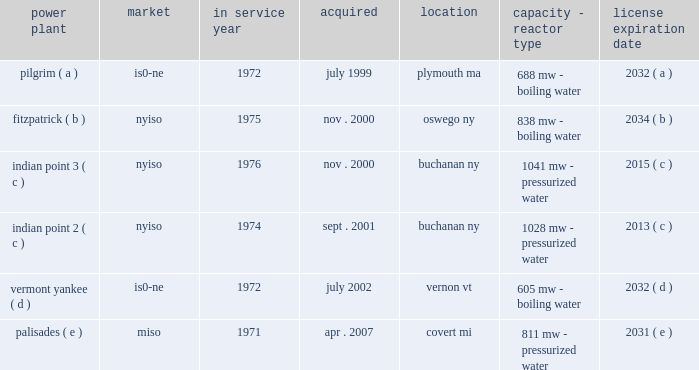Part i item 1 entergy corporation , utility operating companies , and system energy including the continued effectiveness of the clean energy standards/zero emissions credit program ( ces/zec ) , the establishment of certain long-term agreements on acceptable terms with the energy research and development authority of the state of new york in connection with the ces/zec program , and nypsc approval of the transaction on acceptable terms , entergy refueled the fitzpatrick plant in january and february 2017 .
In october 2015 , entergy determined that it would close the pilgrim plant .
The decision came after management 2019s extensive analysis of the economics and operating life of the plant following the nrc 2019s decision in september 2015 to place the plant in its 201cmultiple/repetitive degraded cornerstone column 201d ( column 4 ) of its reactor oversight process action matrix .
The pilgrim plant is expected to cease operations on may 31 , 2019 , after refueling in the spring of 2017 and operating through the end of that fuel cycle .
In december 2015 , entergy wholesale commodities closed on the sale of its 583 mw rhode island state energy center ( risec ) , in johnston , rhode island .
The base sales price , excluding adjustments , was approximately $ 490 million .
Entergy wholesale commodities purchased risec for $ 346 million in december 2011 .
In december 2016 , entergy announced that it reached an agreement with consumers energy to terminate the ppa for the palisades plant on may 31 , 2018 .
Pursuant to the ppa termination agreement , consumers energy will pay entergy $ 172 million for the early termination of the ppa .
The ppa termination agreement is subject to regulatory approvals .
Separately , and assuming regulatory approvals are obtained for the ppa termination agreement , entergy intends to shut down the palisades nuclear power plant permanently on october 1 , 2018 , after refueling in the spring of 2017 and operating through the end of that fuel cycle .
Entergy expects to enter into a new ppa with consumers energy under which the plant would continue to operate through october 1 , 2018 .
In january 2017 , entergy announced that it reached a settlement with new york state to shut down indian point 2 by april 30 , 2020 and indian point 3 by april 30 , 2021 , and resolve all new york state-initiated legal challenges to indian point 2019s operating license renewal .
As part of the settlement , new york state has agreed to issue indian point 2019s water quality certification and coastal zone management act consistency certification and to withdraw its objection to license renewal before the nrc .
New york state also has agreed to issue a water discharge permit , which is required regardless of whether the plant is seeking a renewed nrc license .
The shutdowns are conditioned , among other things , upon such actions being taken by new york state .
Even without opposition , the nrc license renewal process is expected to continue at least into 2018 .
With the settlement concerning indian point , entergy now has announced plans for the disposition of all of the entergy wholesale commodities nuclear power plants , including the sales of vermont yankee and fitzpatrick , and the earlier than previously expected shutdowns of pilgrim , palisades , indian point 2 , and indian point 3 .
See 201centergy wholesale commodities exit from the merchant power business 201d for further discussion .
Property nuclear generating stations entergy wholesale commodities includes the ownership of the following nuclear power plants : power plant market service year acquired location capacity - reactor type license expiration .

For how many years will entergy corporation run the indian point 3 power plant? 
Computations: (2034 - 2000)
Answer: 34.0. 